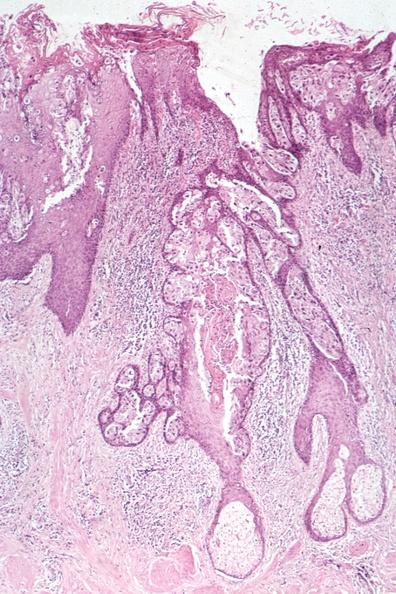s spina bifida present?
Answer the question using a single word or phrase. No 